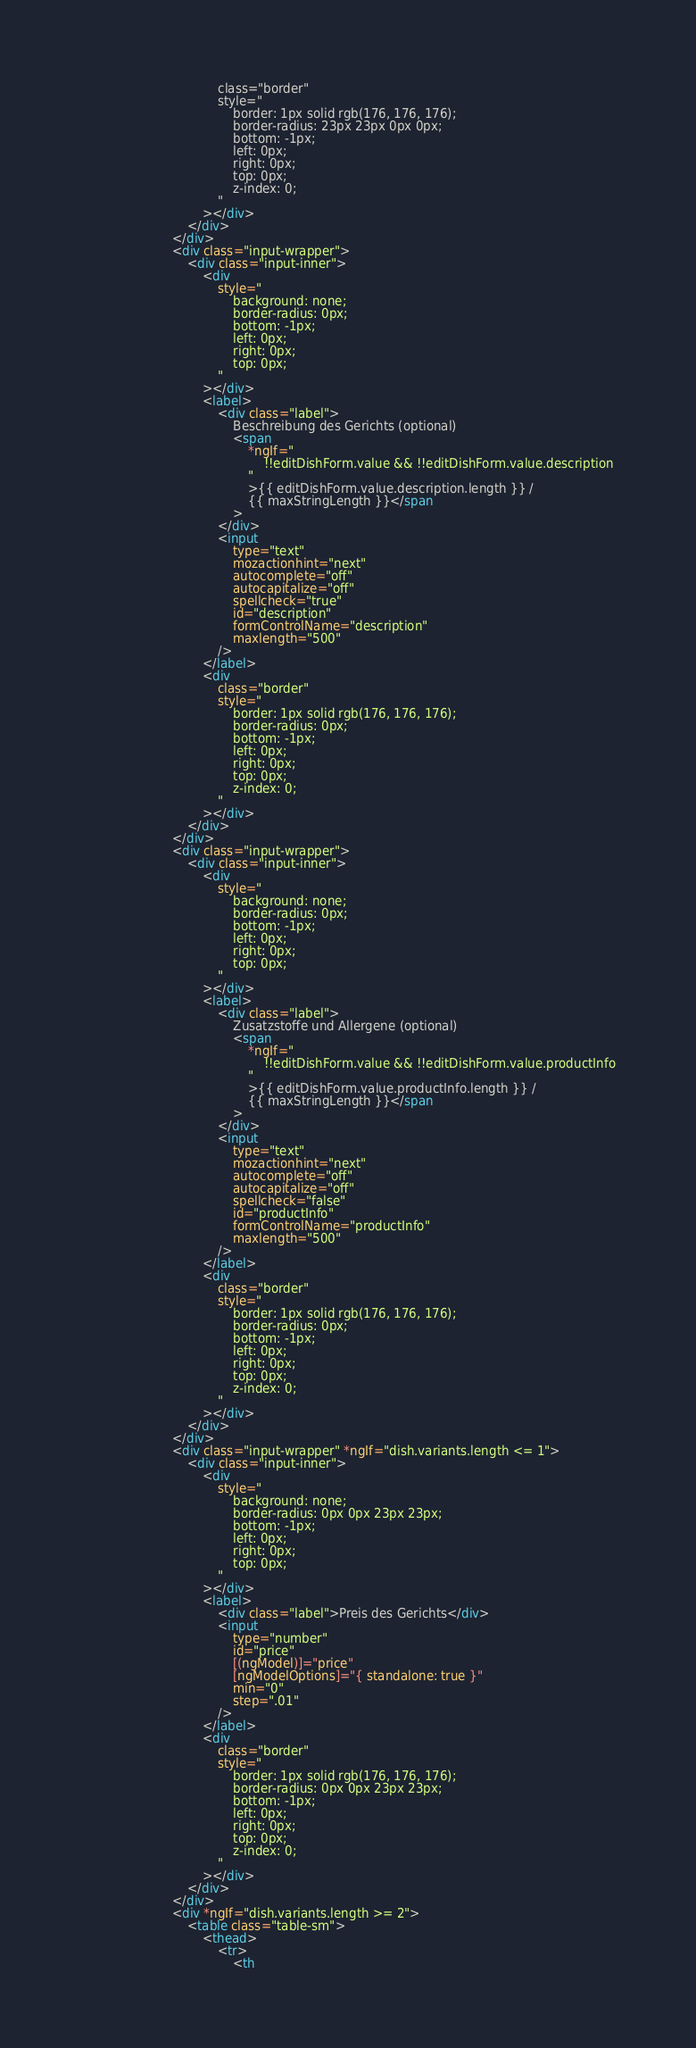<code> <loc_0><loc_0><loc_500><loc_500><_HTML_>									class="border"
									style="
										border: 1px solid rgb(176, 176, 176);
										border-radius: 23px 23px 0px 0px;
										bottom: -1px;
										left: 0px;
										right: 0px;
										top: 0px;
										z-index: 0;
									"
								></div>
							</div>
						</div>
						<div class="input-wrapper">
							<div class="input-inner">
								<div
									style="
										background: none;
										border-radius: 0px;
										bottom: -1px;
										left: 0px;
										right: 0px;
										top: 0px;
									"
								></div>
								<label>
									<div class="label">
										Beschreibung des Gerichts (optional)
										<span
											*ngIf="
												!!editDishForm.value && !!editDishForm.value.description
											"
											>{{ editDishForm.value.description.length }} /
											{{ maxStringLength }}</span
										>
									</div>
									<input
										type="text"
										mozactionhint="next"
										autocomplete="off"
										autocapitalize="off"
										spellcheck="true"
										id="description"
										formControlName="description"
										maxlength="500"
									/>
								</label>
								<div
									class="border"
									style="
										border: 1px solid rgb(176, 176, 176);
										border-radius: 0px;
										bottom: -1px;
										left: 0px;
										right: 0px;
										top: 0px;
										z-index: 0;
									"
								></div>
							</div>
						</div>
						<div class="input-wrapper">
							<div class="input-inner">
								<div
									style="
										background: none;
										border-radius: 0px;
										bottom: -1px;
										left: 0px;
										right: 0px;
										top: 0px;
									"
								></div>
								<label>
									<div class="label">
										Zusatzstoffe und Allergene (optional)
										<span
											*ngIf="
												!!editDishForm.value && !!editDishForm.value.productInfo
											"
											>{{ editDishForm.value.productInfo.length }} /
											{{ maxStringLength }}</span
										>
									</div>
									<input
										type="text"
										mozactionhint="next"
										autocomplete="off"
										autocapitalize="off"
										spellcheck="false"
										id="productInfo"
										formControlName="productInfo"
										maxlength="500"
									/>
								</label>
								<div
									class="border"
									style="
										border: 1px solid rgb(176, 176, 176);
										border-radius: 0px;
										bottom: -1px;
										left: 0px;
										right: 0px;
										top: 0px;
										z-index: 0;
									"
								></div>
							</div>
						</div>
						<div class="input-wrapper" *ngIf="dish.variants.length <= 1">
							<div class="input-inner">
								<div
									style="
										background: none;
										border-radius: 0px 0px 23px 23px;
										bottom: -1px;
										left: 0px;
										right: 0px;
										top: 0px;
									"
								></div>
								<label>
									<div class="label">Preis des Gerichts</div>
									<input
										type="number"
										id="price"
										[(ngModel)]="price"
										[ngModelOptions]="{ standalone: true }"
										min="0"
										step=".01"
									/>
								</label>
								<div
									class="border"
									style="
										border: 1px solid rgb(176, 176, 176);
										border-radius: 0px 0px 23px 23px;
										bottom: -1px;
										left: 0px;
										right: 0px;
										top: 0px;
										z-index: 0;
									"
								></div>
							</div>
						</div>
						<div *ngIf="dish.variants.length >= 2">
							<table class="table-sm">
								<thead>
									<tr>
										<th</code> 